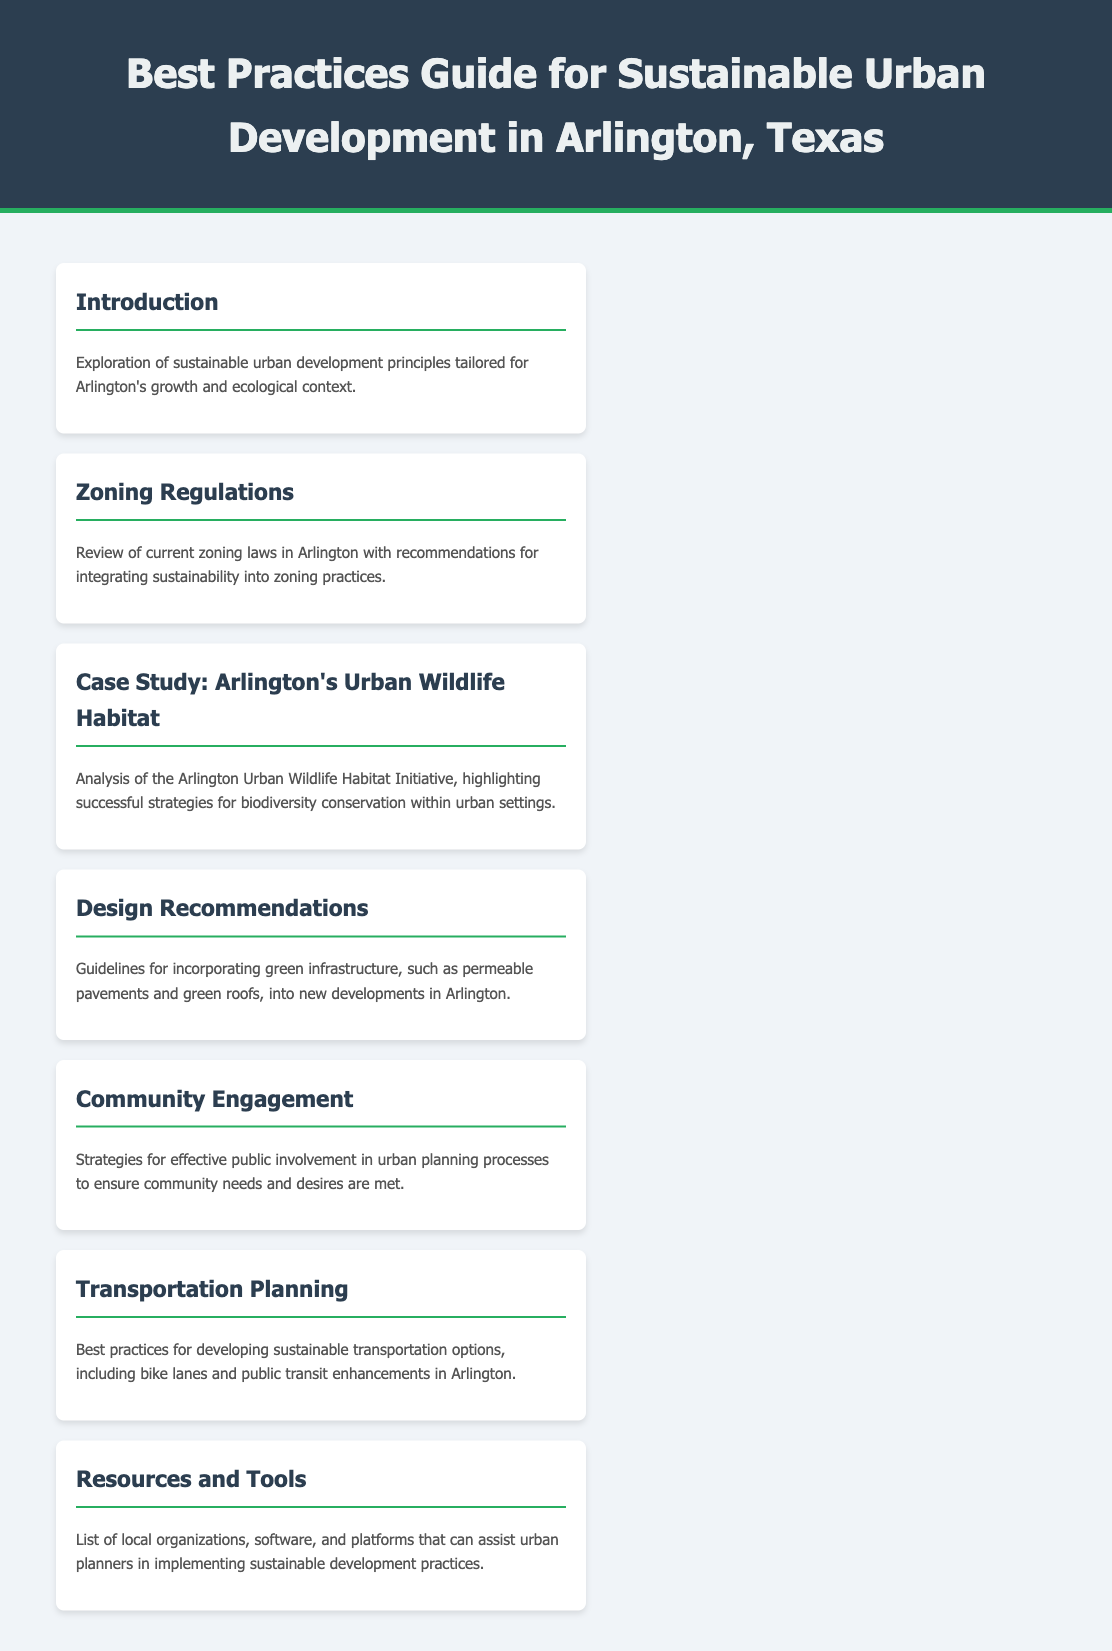what is the title of the document? The title of the document is stated in the header section, indicating the subject of the guide.
Answer: Best Practices Guide for Sustainable Urban Development in Arlington, Texas what is the focus of the introduction? The introduction provides an overview and sets the context for the sustainable urban development principles discussed in the document.
Answer: Sustainable urban development principles tailored for Arlington's growth and ecological context how many case studies are listed in the menu? The menu contains one specific case study focusing on urban wildlife habitat in Arlington.
Answer: 1 what are design recommendations related to? The design recommendations guide the incorporation of environmentally friendly infrastructure into new developments.
Answer: Green infrastructure, such as permeable pavements and green roofs what is a key strategy mentioned for community engagement? The document highlights the importance of public involvement to align urban planning with community needs.
Answer: Effective public involvement which menu item discusses transportation options? The section that covers sustainable modes of transport solutions in Arlington is specifically labeled.
Answer: Transportation Planning what is a resource mentioned for urban planners? The guide provides a list of tools to assist urban planners in sustainable practices, emphasizing local support.
Answer: List of local organizations, software, and platforms 